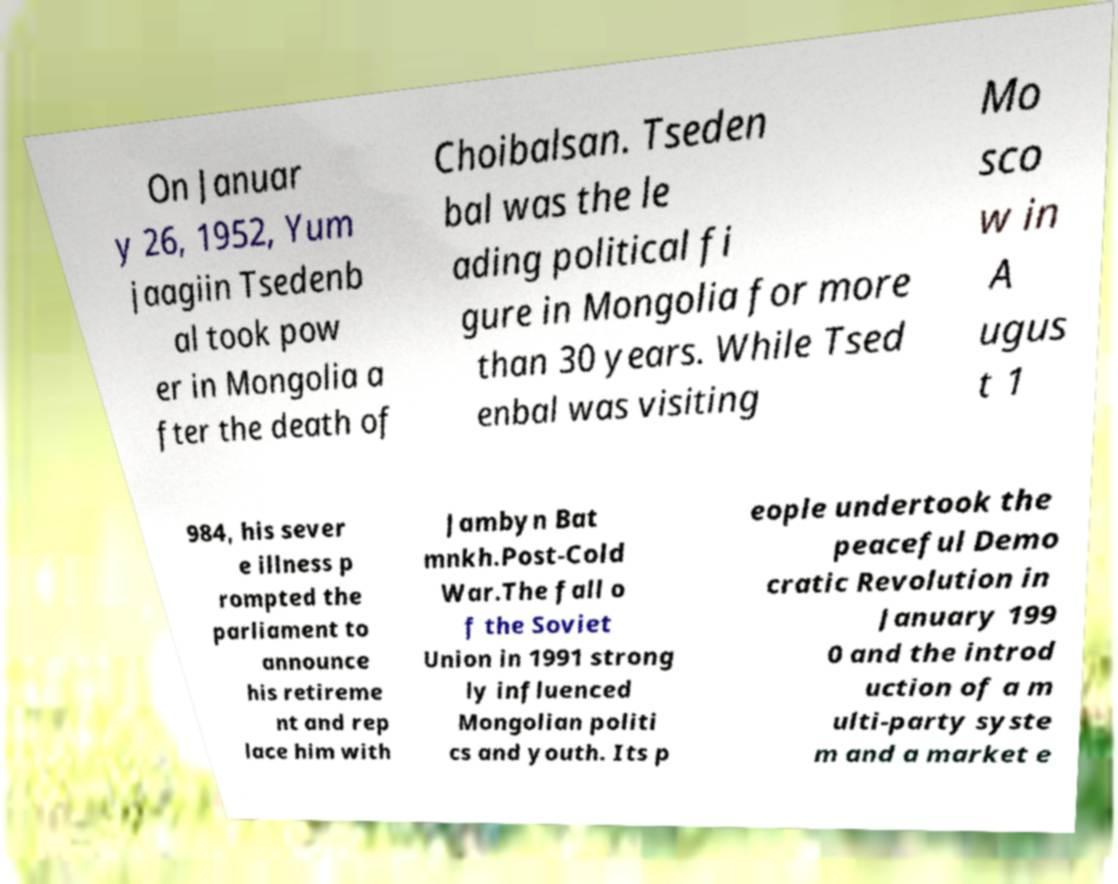What messages or text are displayed in this image? I need them in a readable, typed format. On Januar y 26, 1952, Yum jaagiin Tsedenb al took pow er in Mongolia a fter the death of Choibalsan. Tseden bal was the le ading political fi gure in Mongolia for more than 30 years. While Tsed enbal was visiting Mo sco w in A ugus t 1 984, his sever e illness p rompted the parliament to announce his retireme nt and rep lace him with Jambyn Bat mnkh.Post-Cold War.The fall o f the Soviet Union in 1991 strong ly influenced Mongolian politi cs and youth. Its p eople undertook the peaceful Demo cratic Revolution in January 199 0 and the introd uction of a m ulti-party syste m and a market e 